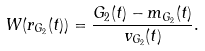Convert formula to latex. <formula><loc_0><loc_0><loc_500><loc_500>W ( r _ { G _ { 2 } } ( t ) ) = \frac { G _ { 2 } ( t ) - m _ { G _ { 2 } } ( t ) } { v _ { G _ { 2 } } ( t ) } .</formula> 